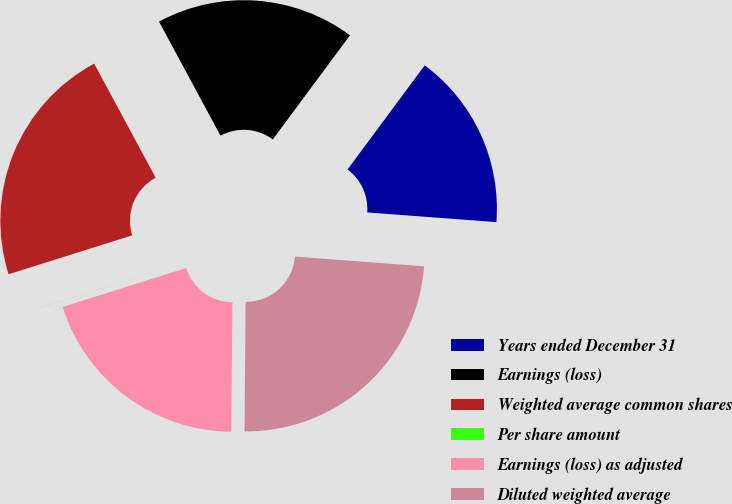Convert chart to OTSL. <chart><loc_0><loc_0><loc_500><loc_500><pie_chart><fcel>Years ended December 31<fcel>Earnings (loss)<fcel>Weighted average common shares<fcel>Per share amount<fcel>Earnings (loss) as adjusted<fcel>Diluted weighted average<nl><fcel>16.04%<fcel>18.02%<fcel>21.98%<fcel>0.01%<fcel>20.0%<fcel>23.95%<nl></chart> 